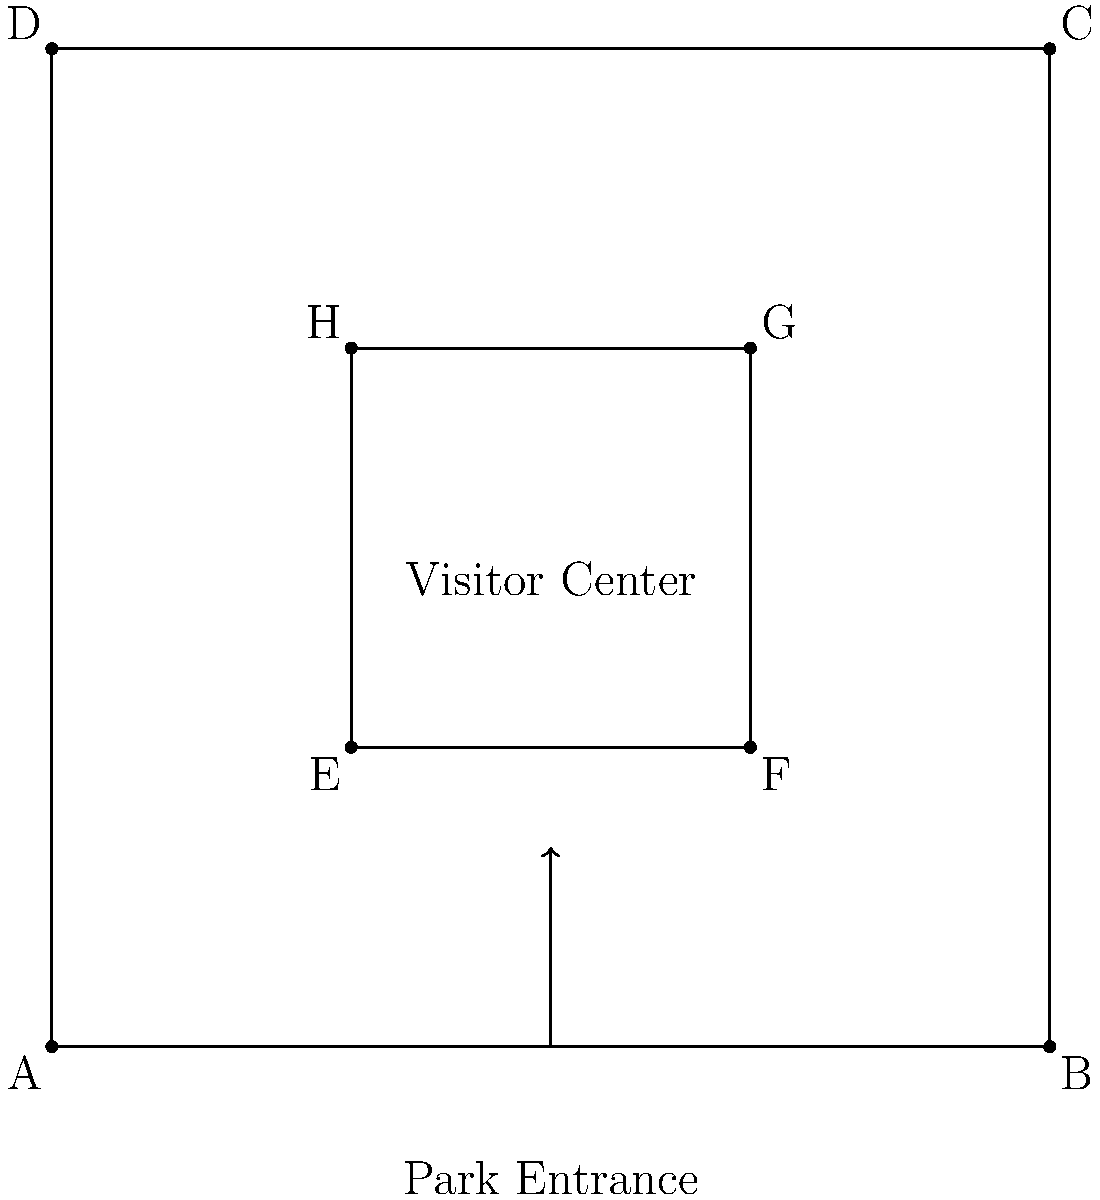Given the park layout shown above, where should the main informational sign be placed to maximize visibility for visitors entering the park and those visiting the central area? To determine the best placement for the main informational sign, we need to consider the following factors:

1. Visitor flow: The arrow indicates that visitors enter from the bottom of the diagram.
2. Central area: The inner rectangle (EFGH) represents the Visitor Center, which is likely a high-traffic area.
3. Visibility: The sign should be visible to both entering visitors and those in the central area.

Step-by-step analysis:
1. Point A is too far to the left and may be missed by entering visitors.
2. Point B is at the entrance but too far right, potentially missed by some visitors.
3. Points C and D are too far from the entrance and not easily visible to entering visitors.
4. Points G and H are inside the park but not visible from the entrance.
5. Point F is visible from the entrance but may obstruct the path to the Visitor Center.
6. Point E is the optimal location because:
   a) It's visible to visitors entering the park.
   b) It's close to the path leading to the Visitor Center.
   c) It doesn't obstruct the main walking paths.
   d) It's visible from the central area (Visitor Center).

Therefore, the best placement for the main informational sign is at point E.
Answer: Point E 